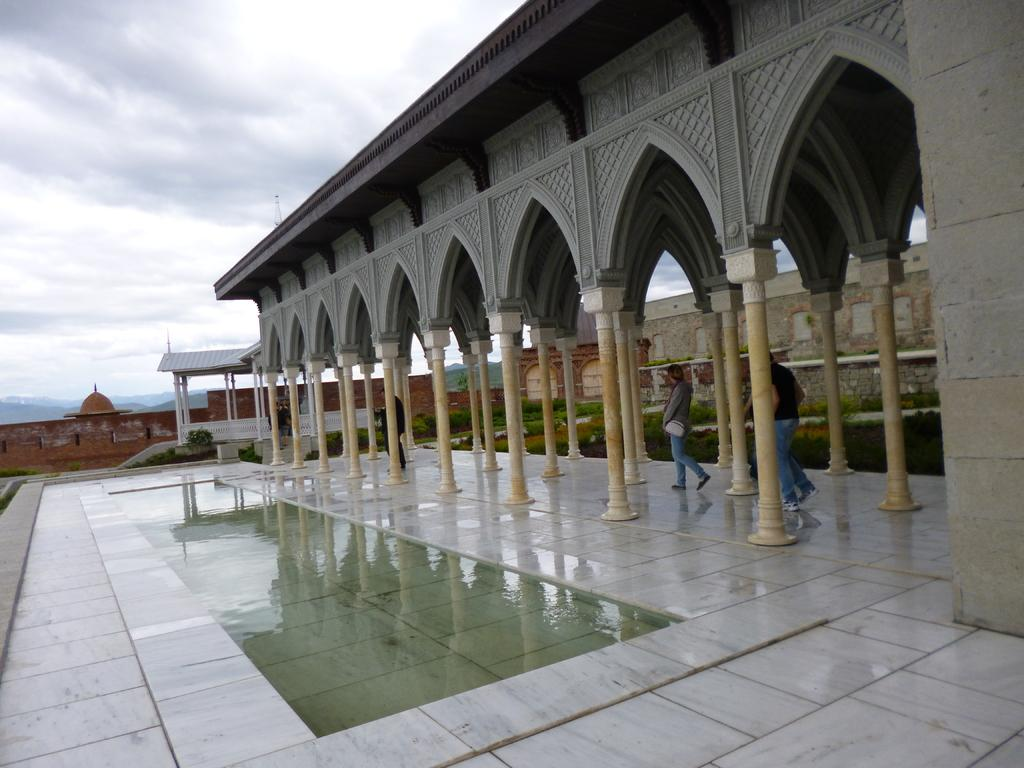What architectural features can be seen in the image? There are pillars, a shed, walls, and railings in the image. What type of vegetation is present in the image? There are plants in the image. Are there any people in the image? Yes, there are people in the image. What natural elements can be seen in the image? There is water visible in the image, and there are hills in the background of the image. What is the condition of the sky in the background of the image? The sky is cloudy in the background of the image. Are there any decorative elements in the image? Yes, there are carvings in the image. What type of blade can be seen in the image? There is no blade present in the image. What type of seed is growing on the plants in the image? There is no information about the type of seed growing on the plants in the image. Can you see any monkeys in the image? There are no monkeys present in the image. 